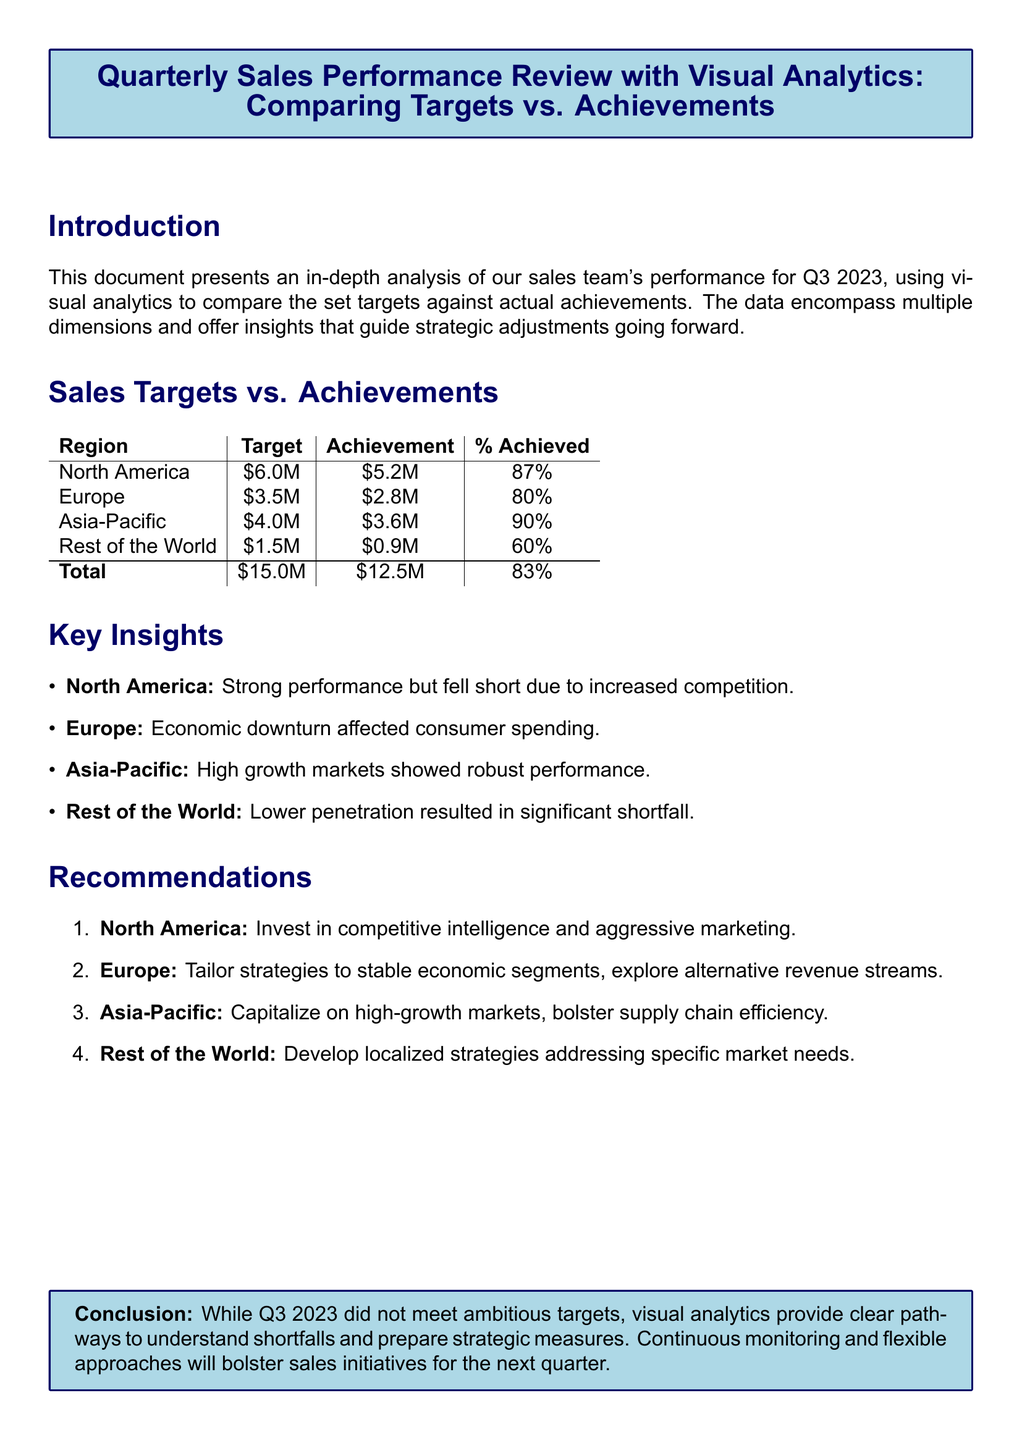What is the target revenue for North America? The target revenue for North America is stated directly in the table as \$6.0M.
Answer: \$6.0M What was the achievement for Europe? The achievement for Europe is found in the sales table as \$2.8M.
Answer: \$2.8M What percentage of the target was achieved in the Asia-Pacific region? The percentage achieved for Asia-Pacific is given in the table as 90%.
Answer: 90% Which region had the lowest percentage of target achievement? The region with the lowest percentage of target achievement is the Rest of the World, at 60%.
Answer: Rest of the World What is the total percentage achieved across all regions? The total percentage achieved is listed in the summary as 83%.
Answer: 83% What key challenge affected sales in Europe? The document states that the economic downturn affected consumer spending in Europe.
Answer: Economic downturn What recommendation is made for North America? The recommendation for North America is to invest in competitive intelligence and aggressive marketing.
Answer: Invest in competitive intelligence and aggressive marketing Which region showed robust performance according to key insights? The Asia-Pacific region is highlighted as showing robust performance in the key insights section.
Answer: Asia-Pacific What was the total target revenue across all regions? The total target revenue is provided in the table summary as \$15.0M.
Answer: \$15.0M 